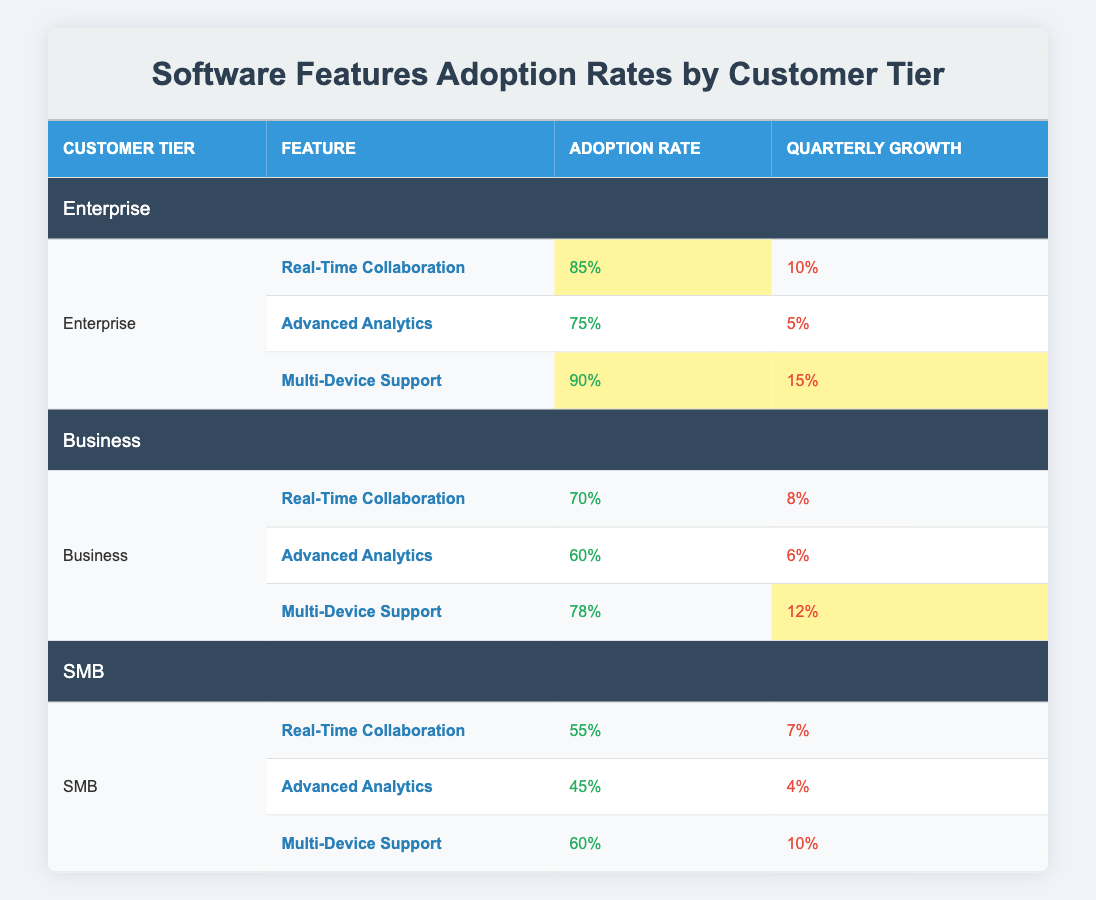What is the adoption rate for Real-Time Collaboration in the Enterprise tier? The table under the "Enterprise" tier shows the feature "Real-Time Collaboration" with an adoption rate of "85%".
Answer: 85% Which feature has the highest adoption rate in the Business tier? Looking at the "Business" tier, the feature "Multi-Device Support" has the highest adoption rate at "78%" compared to "Real-Time Collaboration" (70%) and "Advanced Analytics" (60%).
Answer: Multi-Device Support (78%) Is the adoption rate for Advanced Analytics in the SMB tier greater than 50%? In the SMB tier, the adoption rate for "Advanced Analytics" is listed as "45%", which is less than 50%.
Answer: No What is the quarterly growth for Multi-Device Support across all tiers? The quarterly growth for "Multi-Device Support" in the Enterprise tier is "15%", in Business it is "12%", and in SMB, it is "10%". Summing these gives a total of 15 + 12 + 10 = 37%.
Answer: 37% Which tier shows the least adoption for Real-Time Collaboration? Upon reviewing the adoption rates in all tiers, the SMB tier has the least adoption for "Real-Time Collaboration" at "55%", compared to 70% in Business and 85% in Enterprise.
Answer: SMB What feature has the same adoption rate growth in both Enterprise and Business tiers? The "Advanced Analytics" feature has "5%" quarterly growth in the Enterprise tier and "6%" quarterly growth in the Business tier. There are no features with identical growth rates.
Answer: None What is the average adoption rate for Multi-Device Support across all customer tiers? The adoption rates for Multi-Device Support are 90% (Enterprise), 78% (Business), and 60% (SMB). Adding these gives 90 + 78 + 60 = 228, and dividing by 3 gives an average of 76%.
Answer: 76% True or False: The growth rate for Advanced Analytics is higher in the Business tier than in the Enterprise tier. The growth rate for "Advanced Analytics" in the Business tier is "6%", while in the Enterprise tier, it is "5%". Therefore, it is higher in the Business tier.
Answer: True What is the relationship between Real-Time Collaboration adoption rates and their quarterly growth within the tiers? "Real-Time Collaboration" in the Enterprise tier has an adoption rate of 85% with 10% growth, in Business it’s 70% with 8% growth, and in SMB it’s 55% with 7% growth. The higher the adoption rate, the higher the growth in this case.
Answer: Higher adoption rates correlate with higher growth 